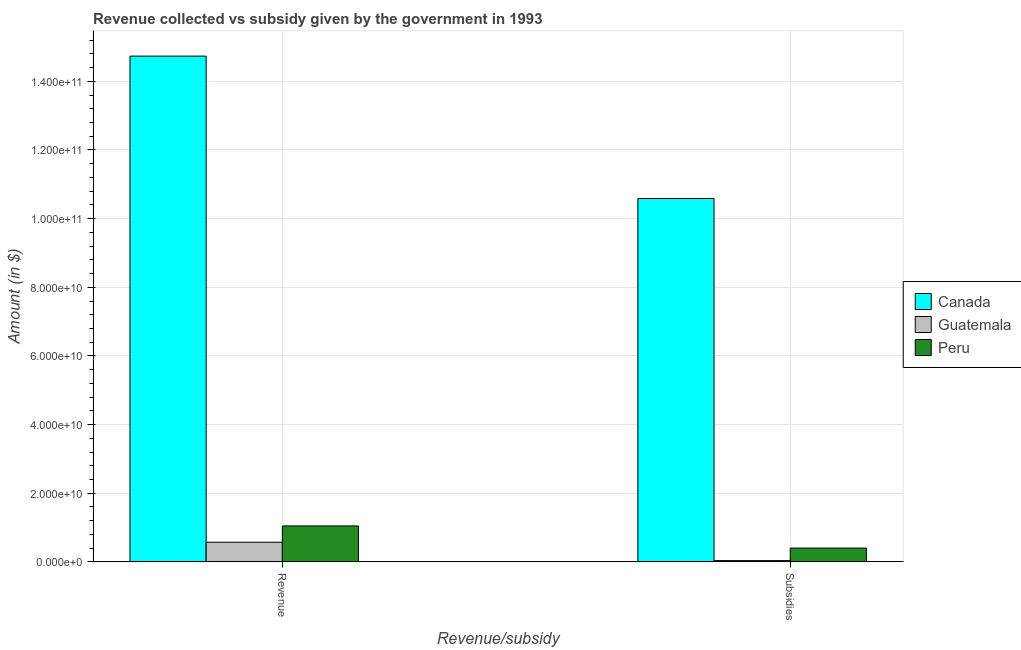How many different coloured bars are there?
Offer a terse response. 3. Are the number of bars per tick equal to the number of legend labels?
Offer a terse response. Yes. What is the label of the 2nd group of bars from the left?
Offer a terse response. Subsidies. What is the amount of subsidies given in Peru?
Offer a very short reply. 4.02e+09. Across all countries, what is the maximum amount of revenue collected?
Offer a very short reply. 1.47e+11. Across all countries, what is the minimum amount of revenue collected?
Provide a succinct answer. 5.74e+09. In which country was the amount of revenue collected maximum?
Provide a succinct answer. Canada. In which country was the amount of revenue collected minimum?
Ensure brevity in your answer.  Guatemala. What is the total amount of revenue collected in the graph?
Offer a terse response. 1.64e+11. What is the difference between the amount of subsidies given in Guatemala and that in Peru?
Your answer should be very brief. -3.64e+09. What is the difference between the amount of revenue collected in Canada and the amount of subsidies given in Peru?
Give a very brief answer. 1.43e+11. What is the average amount of subsidies given per country?
Make the answer very short. 3.68e+1. What is the difference between the amount of subsidies given and amount of revenue collected in Canada?
Your answer should be compact. -4.15e+1. In how many countries, is the amount of subsidies given greater than 56000000000 $?
Offer a terse response. 1. What is the ratio of the amount of subsidies given in Peru to that in Guatemala?
Provide a succinct answer. 10.57. Is the amount of subsidies given in Peru less than that in Guatemala?
Give a very brief answer. No. In how many countries, is the amount of revenue collected greater than the average amount of revenue collected taken over all countries?
Give a very brief answer. 1. What does the 1st bar from the left in Subsidies represents?
Your answer should be very brief. Canada. What does the 2nd bar from the right in Subsidies represents?
Offer a terse response. Guatemala. What is the difference between two consecutive major ticks on the Y-axis?
Offer a terse response. 2.00e+1. Are the values on the major ticks of Y-axis written in scientific E-notation?
Provide a short and direct response. Yes. Does the graph contain grids?
Your answer should be very brief. Yes. How many legend labels are there?
Give a very brief answer. 3. What is the title of the graph?
Your answer should be compact. Revenue collected vs subsidy given by the government in 1993. What is the label or title of the X-axis?
Provide a succinct answer. Revenue/subsidy. What is the label or title of the Y-axis?
Offer a very short reply. Amount (in $). What is the Amount (in $) of Canada in Revenue?
Provide a succinct answer. 1.47e+11. What is the Amount (in $) of Guatemala in Revenue?
Your answer should be very brief. 5.74e+09. What is the Amount (in $) in Peru in Revenue?
Provide a succinct answer. 1.05e+1. What is the Amount (in $) of Canada in Subsidies?
Provide a short and direct response. 1.06e+11. What is the Amount (in $) in Guatemala in Subsidies?
Your response must be concise. 3.81e+08. What is the Amount (in $) in Peru in Subsidies?
Make the answer very short. 4.02e+09. Across all Revenue/subsidy, what is the maximum Amount (in $) in Canada?
Offer a terse response. 1.47e+11. Across all Revenue/subsidy, what is the maximum Amount (in $) in Guatemala?
Offer a terse response. 5.74e+09. Across all Revenue/subsidy, what is the maximum Amount (in $) in Peru?
Provide a succinct answer. 1.05e+1. Across all Revenue/subsidy, what is the minimum Amount (in $) of Canada?
Your response must be concise. 1.06e+11. Across all Revenue/subsidy, what is the minimum Amount (in $) of Guatemala?
Your answer should be compact. 3.81e+08. Across all Revenue/subsidy, what is the minimum Amount (in $) in Peru?
Provide a short and direct response. 4.02e+09. What is the total Amount (in $) of Canada in the graph?
Make the answer very short. 2.53e+11. What is the total Amount (in $) in Guatemala in the graph?
Your answer should be compact. 6.12e+09. What is the total Amount (in $) in Peru in the graph?
Provide a short and direct response. 1.45e+1. What is the difference between the Amount (in $) in Canada in Revenue and that in Subsidies?
Provide a short and direct response. 4.15e+1. What is the difference between the Amount (in $) of Guatemala in Revenue and that in Subsidies?
Your response must be concise. 5.36e+09. What is the difference between the Amount (in $) of Peru in Revenue and that in Subsidies?
Offer a terse response. 6.45e+09. What is the difference between the Amount (in $) in Canada in Revenue and the Amount (in $) in Guatemala in Subsidies?
Keep it short and to the point. 1.47e+11. What is the difference between the Amount (in $) in Canada in Revenue and the Amount (in $) in Peru in Subsidies?
Your answer should be very brief. 1.43e+11. What is the difference between the Amount (in $) of Guatemala in Revenue and the Amount (in $) of Peru in Subsidies?
Your answer should be very brief. 1.71e+09. What is the average Amount (in $) of Canada per Revenue/subsidy?
Give a very brief answer. 1.27e+11. What is the average Amount (in $) in Guatemala per Revenue/subsidy?
Your answer should be very brief. 3.06e+09. What is the average Amount (in $) in Peru per Revenue/subsidy?
Your answer should be very brief. 7.25e+09. What is the difference between the Amount (in $) of Canada and Amount (in $) of Guatemala in Revenue?
Ensure brevity in your answer.  1.42e+11. What is the difference between the Amount (in $) of Canada and Amount (in $) of Peru in Revenue?
Provide a succinct answer. 1.37e+11. What is the difference between the Amount (in $) of Guatemala and Amount (in $) of Peru in Revenue?
Your response must be concise. -4.74e+09. What is the difference between the Amount (in $) of Canada and Amount (in $) of Guatemala in Subsidies?
Offer a terse response. 1.05e+11. What is the difference between the Amount (in $) of Canada and Amount (in $) of Peru in Subsidies?
Provide a short and direct response. 1.02e+11. What is the difference between the Amount (in $) of Guatemala and Amount (in $) of Peru in Subsidies?
Offer a very short reply. -3.64e+09. What is the ratio of the Amount (in $) of Canada in Revenue to that in Subsidies?
Provide a succinct answer. 1.39. What is the ratio of the Amount (in $) of Guatemala in Revenue to that in Subsidies?
Provide a short and direct response. 15.07. What is the ratio of the Amount (in $) in Peru in Revenue to that in Subsidies?
Your response must be concise. 2.6. What is the difference between the highest and the second highest Amount (in $) of Canada?
Your response must be concise. 4.15e+1. What is the difference between the highest and the second highest Amount (in $) in Guatemala?
Make the answer very short. 5.36e+09. What is the difference between the highest and the second highest Amount (in $) of Peru?
Keep it short and to the point. 6.45e+09. What is the difference between the highest and the lowest Amount (in $) of Canada?
Provide a short and direct response. 4.15e+1. What is the difference between the highest and the lowest Amount (in $) in Guatemala?
Your answer should be very brief. 5.36e+09. What is the difference between the highest and the lowest Amount (in $) in Peru?
Your answer should be compact. 6.45e+09. 